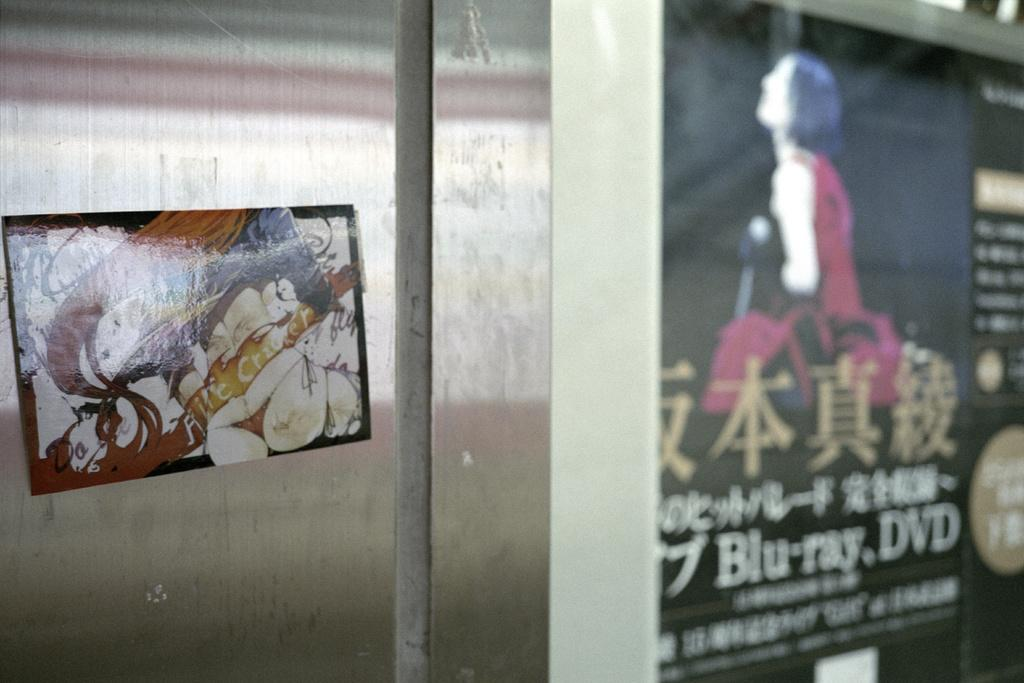What type of structure can be seen in the image? There is a wall in the image. What else is present in the image besides the wall? There are boards in the image. What type of wool is being used for the flight in the image? There is no wool or flight present in the image; it only features a wall and boards. 